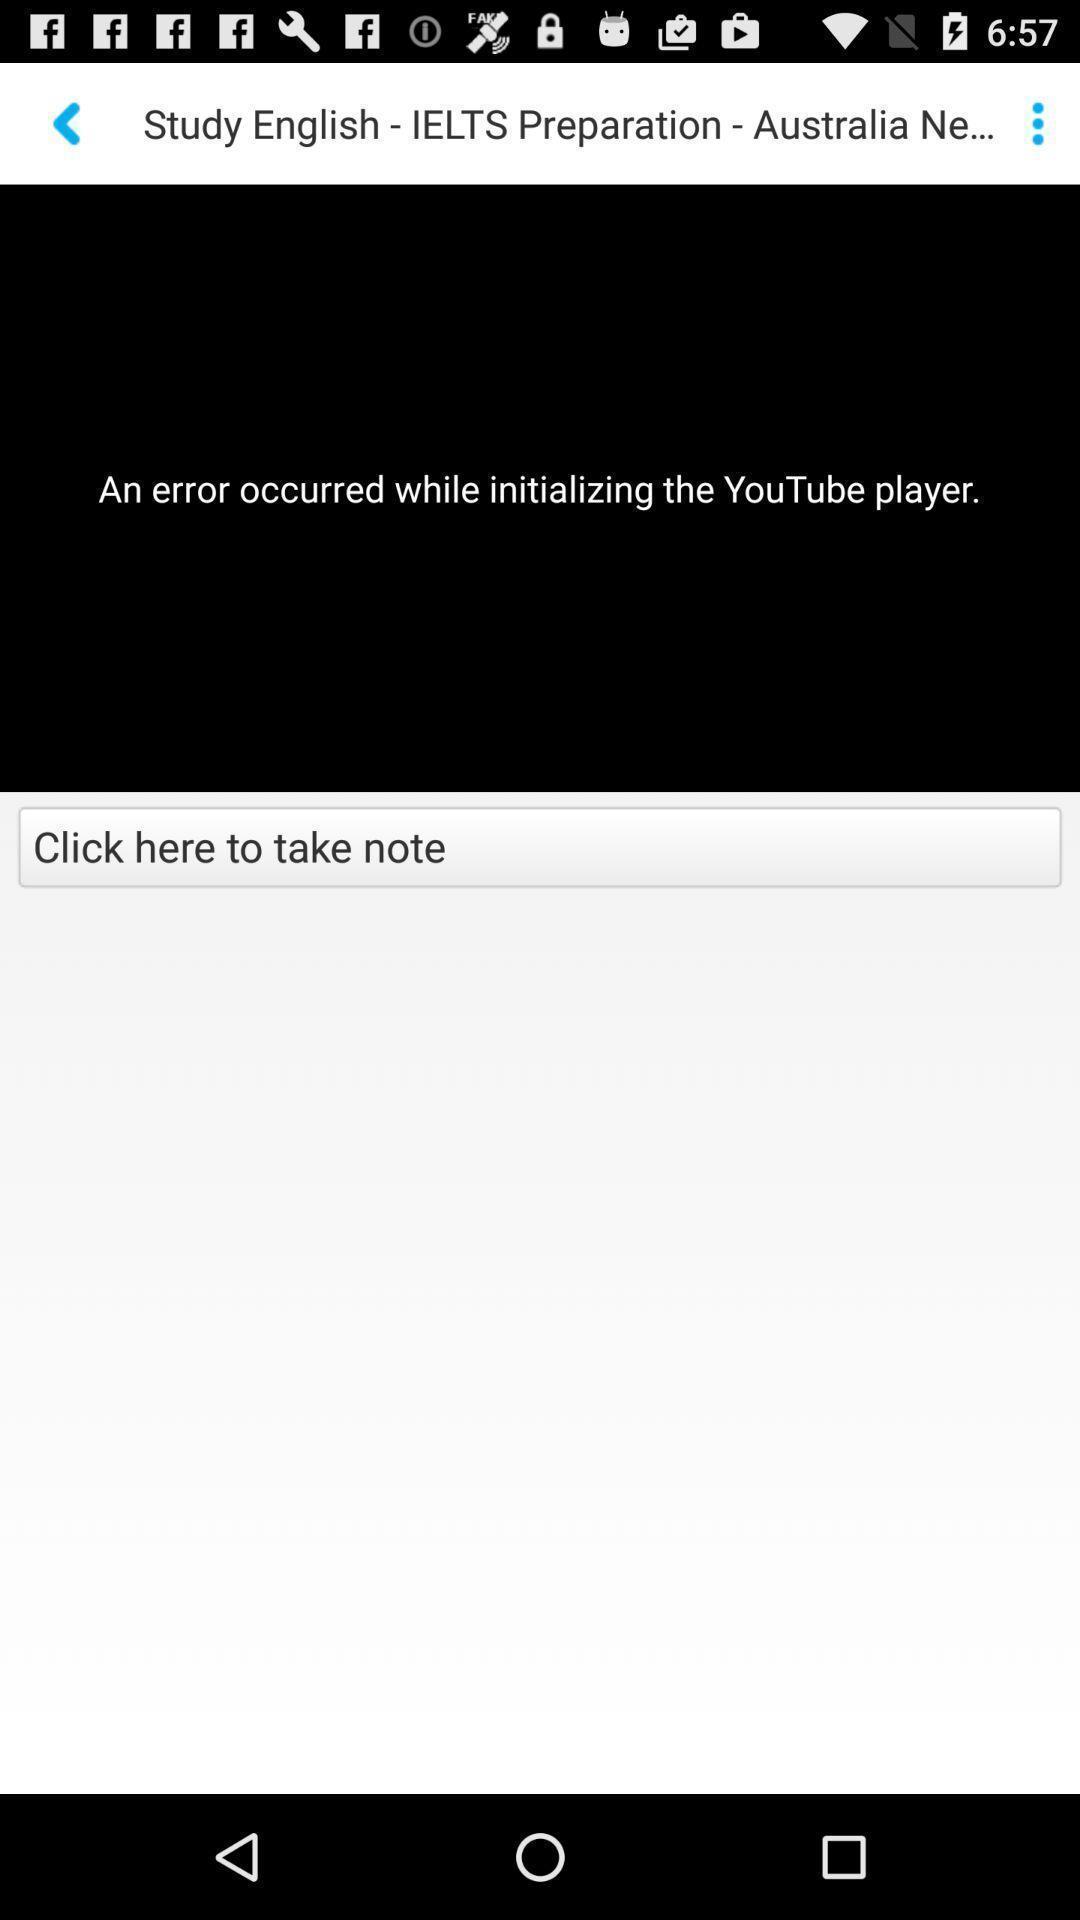Tell me about the visual elements in this screen capture. Page showing error in playing video in learning app. 